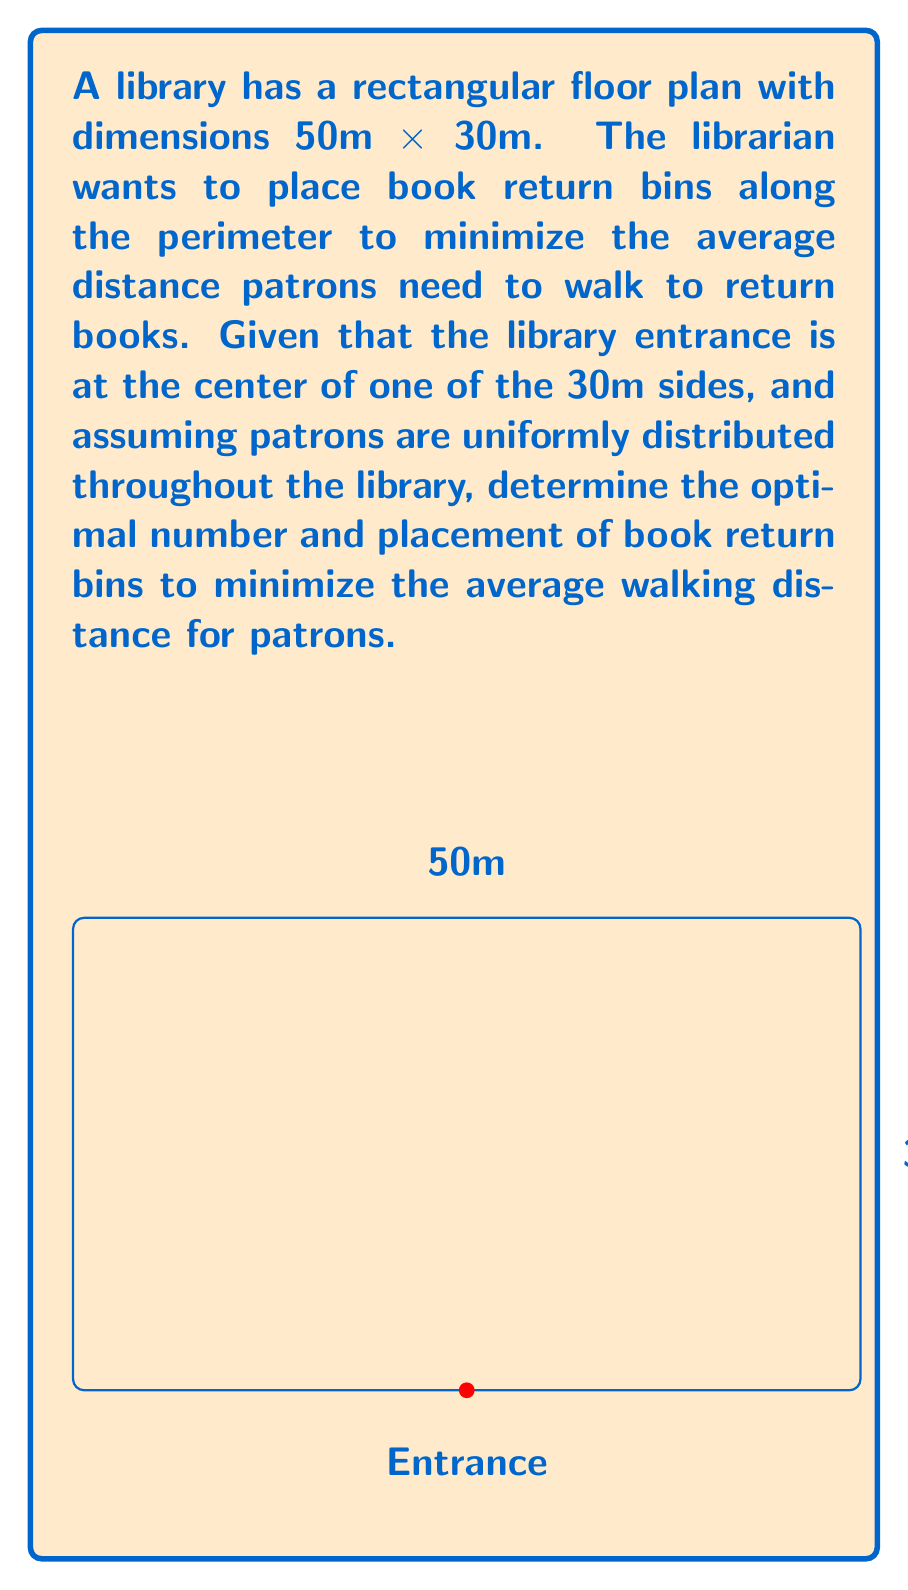Solve this math problem. To solve this optimization problem, we'll use principles from control theory and calculus. Let's approach this step-by-step:

1) First, we need to model the average distance a patron needs to walk. Let's assume $n$ bins are placed equidistantly along the perimeter.

2) The perimeter of the library is $2(50+30) = 160$ meters. With $n$ bins, they will be spaced $\frac{160}{n}$ meters apart.

3) The maximum distance a patron would need to walk to reach a bin is half this distance: $\frac{80}{n}$ meters.

4) Assuming a uniform distribution of patrons, the average distance walked will be half of the maximum distance: $\frac{40}{n}$ meters.

5) However, we also need to consider the distance from the entrance to the nearest bin. This distance will be $\frac{80}{n}$ meters on average.

6) So, the total average distance $D(n)$ a patron needs to walk is:

   $$D(n) = \frac{40}{n} + \frac{80}{n} = \frac{120}{n}$$

7) To find the optimal number of bins, we need to consider the cost of installing and maintaining each bin. Let's assume this cost is proportional to the number of bins, say $cn$ where $c$ is a constant.

8) Our total cost function $C(n)$ is then:

   $$C(n) = \frac{120}{n} + cn$$

9) To minimize this, we differentiate with respect to $n$ and set it to zero:

   $$\frac{dC}{dn} = -\frac{120}{n^2} + c = 0$$

10) Solving this:

    $$n = \sqrt{\frac{120}{c}}$$

11) The actual value of $n$ will depend on the cost constant $c$. For example, if $c = 3$, then $n \approx 6.32$. Since we need a whole number of bins, we'd round to 6 or 7 bins.

12) With 6 bins, they would be placed approximately every 26.67 meters along the perimeter, starting from the entrance.
Answer: 6 or 7 bins, placed equidistantly along the perimeter, starting from the entrance. 